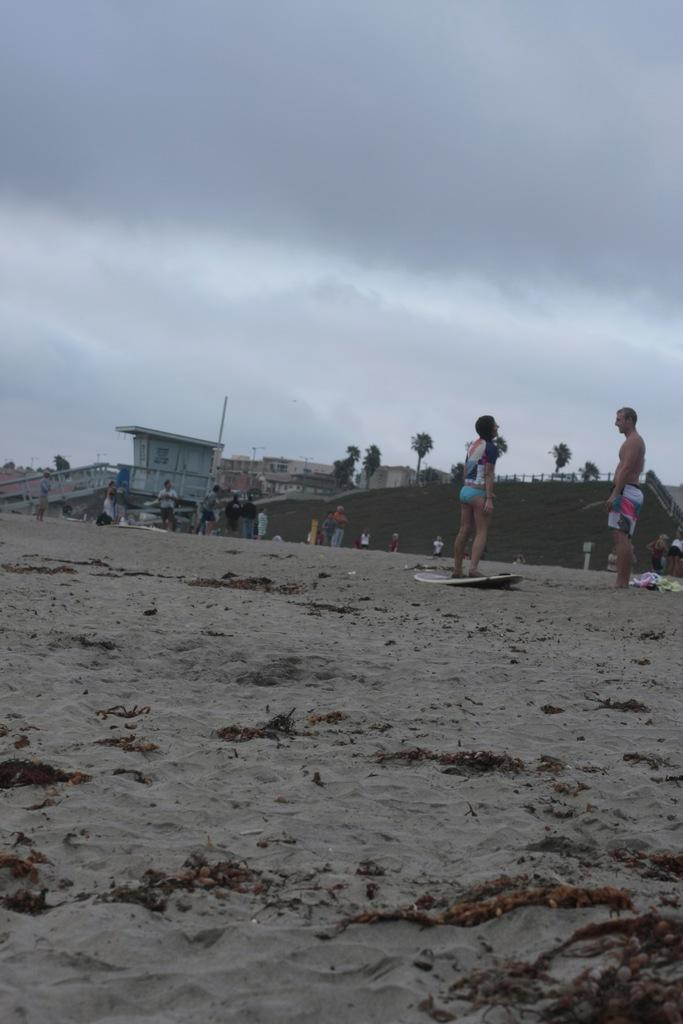What is the condition of the sky in the image? The sky is cloudy in the image. What is the person on the surfboard doing? The person is standing on a surfboard. How many people can be seen in the image? There are people visible in the image. What type of structures are present in the image? There are buildings in the image. What type of vegetation is present in the image? There are trees in the image. What type of yard can be seen in the image? There is no yard visible in the image. What type of twig is being used as a utensil by the person on the surfboard? There is no twig present in the image, and the person on the surfboard is not using any utensils. 